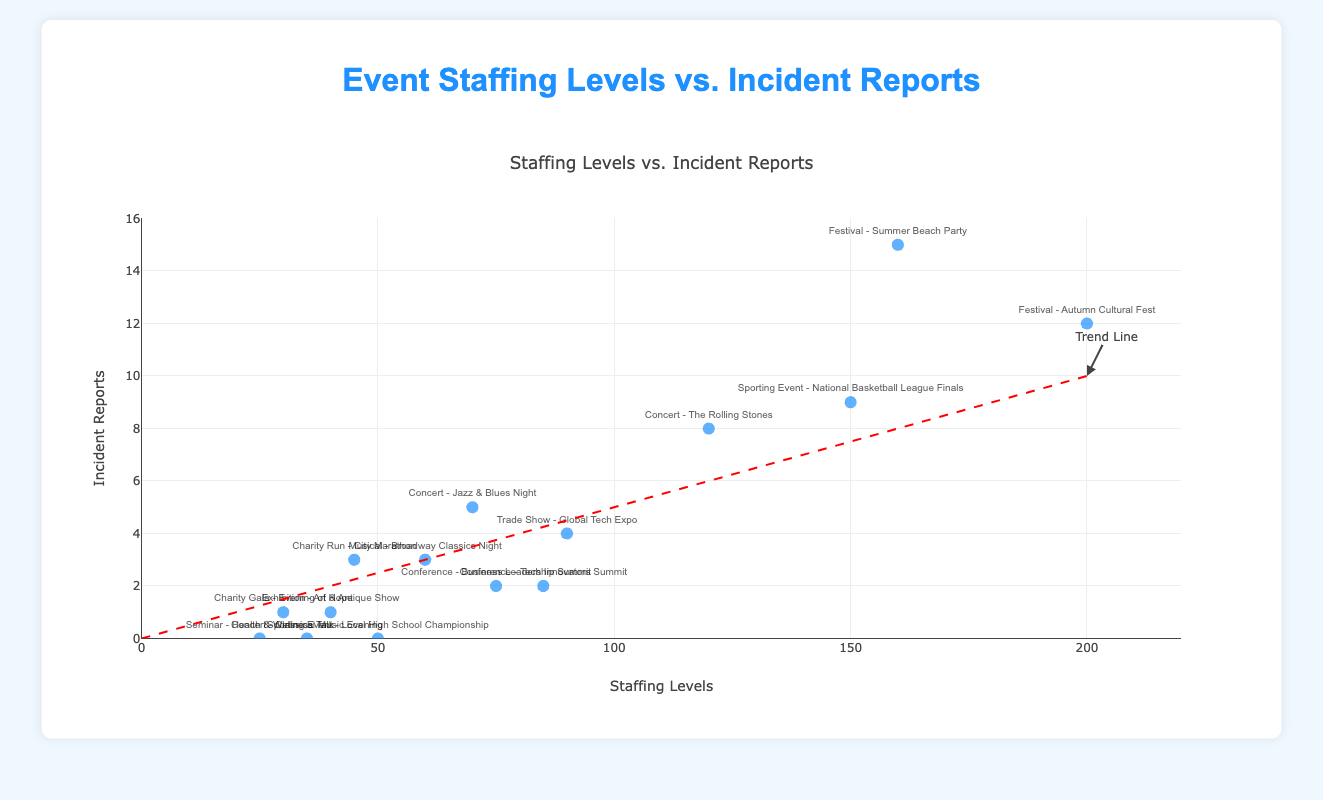What is the title of the scatter plot? The title is displayed at the top center of the plot, reading "Staffing Levels vs. Incident Reports".
Answer: Staffing Levels vs. Incident Reports How many events reported zero incidents? By checking the points plotted on the y-axis at zero incident reports, we see three events at (50, 0), (25, 0), and (35, 0).
Answer: 3 Which event had the highest number of incident reports? By looking at the highest y-axis value, the festival "Summer Beach Party" is at (160, 15) with 15 incident reports.
Answer: Festival - Summer Beach Party How many events had staffing levels of 100 or more? By checking the x-axis, points starting from 100 and above are at (120, 8), (200, 12), (150, 9), and (160, 15), summing up to four events.
Answer: 4 What's the difference in incident reports between the "Autumn Cultural Fest" and the "Tech Innovators Summit"? "Autumn Cultural Fest" has 12 incident reports, and "Tech Innovators Summit" has 2. Therefore, 12 - 2 = 10.
Answer: 10 What is the average number of incident reports for events with staffing levels under 50? Events with staffing levels under 50: (30, 1), (40, 1), (25, 0), (35, 0), (45, 3). Number of incidents: 1 + 1 + 0 + 0 + 3 = 5. Average = 5/5 = 1.
Answer: 1 Is there a general trend of incidents increasing or decreasing with higher staffing levels? The trend line, represented by the dashed red line sloping upwards, suggests that incident reports generally increase as staffing levels rise.
Answer: Increasing Which event had the lowest number of staff and did it report any incidents? "Seminar - Health & Wellness Talk" with staffing levels at 25 is the lowest and it reported zero incidents.
Answer: Seminar - Health & Wellness Talk; No incidents How many events with staffing levels of 70 or more had fewer than 10 incident reports? Events: (120, 8), (85, 2), (200, 12), (150, 9), (160, 15), (90, 4), (75, 2), (70, 5). Filtering for incidents < 10: 120-8, 85-2, 150-9, 90-4, 75-2, 70-5 – six events.
Answer: 6 What's the sum of incident reports for the events with the most and least staffing levels? Most: "Autumn Cultural Fest" (200, 12). Least: "Seminar - Health & Wellness Talk" (25, 0). Sum: 12 + 0 = 12.
Answer: 12 Which type of event generally had higher staffing levels, concerts or conferences? By comparing the average staffing levels of concerts (120, 70, 35) and conferences (85, 75), concerts have generally higher staffing levels (Avg. 75 > Avg. 80).
Answer: Concerts 